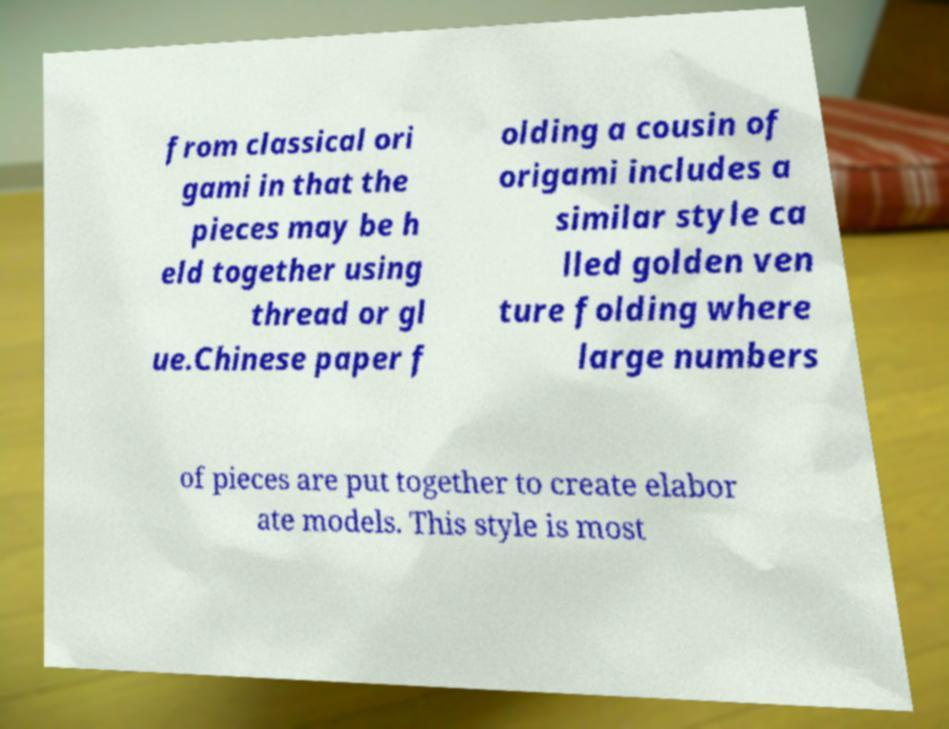Can you read and provide the text displayed in the image?This photo seems to have some interesting text. Can you extract and type it out for me? from classical ori gami in that the pieces may be h eld together using thread or gl ue.Chinese paper f olding a cousin of origami includes a similar style ca lled golden ven ture folding where large numbers of pieces are put together to create elabor ate models. This style is most 